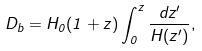Convert formula to latex. <formula><loc_0><loc_0><loc_500><loc_500>D _ { b } = H _ { 0 } ( 1 + z ) \int ^ { z } _ { 0 } \frac { d z ^ { \prime } } { H ( z ^ { \prime } ) } ,</formula> 